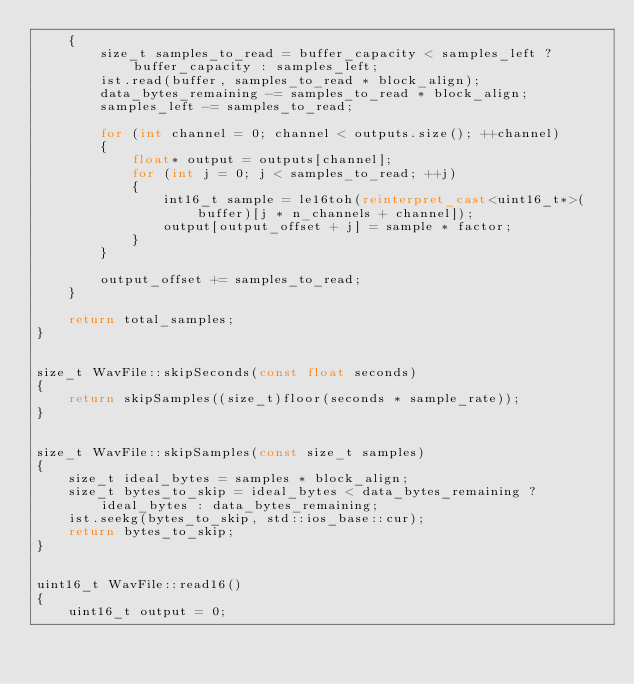<code> <loc_0><loc_0><loc_500><loc_500><_C++_>	{
		size_t samples_to_read = buffer_capacity < samples_left ? buffer_capacity : samples_left;
		ist.read(buffer, samples_to_read * block_align);
		data_bytes_remaining -= samples_to_read * block_align;
		samples_left -= samples_to_read;

		for (int channel = 0; channel < outputs.size(); ++channel)
		{
			float* output = outputs[channel];
			for (int j = 0; j < samples_to_read; ++j)
			{
				int16_t sample = le16toh(reinterpret_cast<uint16_t*>(buffer)[j * n_channels + channel]);
				output[output_offset + j] = sample * factor;
			}
		}

		output_offset += samples_to_read;
	}

	return total_samples;
}


size_t WavFile::skipSeconds(const float seconds)
{
	return skipSamples((size_t)floor(seconds * sample_rate));
}


size_t WavFile::skipSamples(const size_t samples)
{
	size_t ideal_bytes = samples * block_align;
	size_t bytes_to_skip = ideal_bytes < data_bytes_remaining ? ideal_bytes : data_bytes_remaining;
	ist.seekg(bytes_to_skip, std::ios_base::cur);
	return bytes_to_skip;
}


uint16_t WavFile::read16()
{
	uint16_t output = 0;</code> 